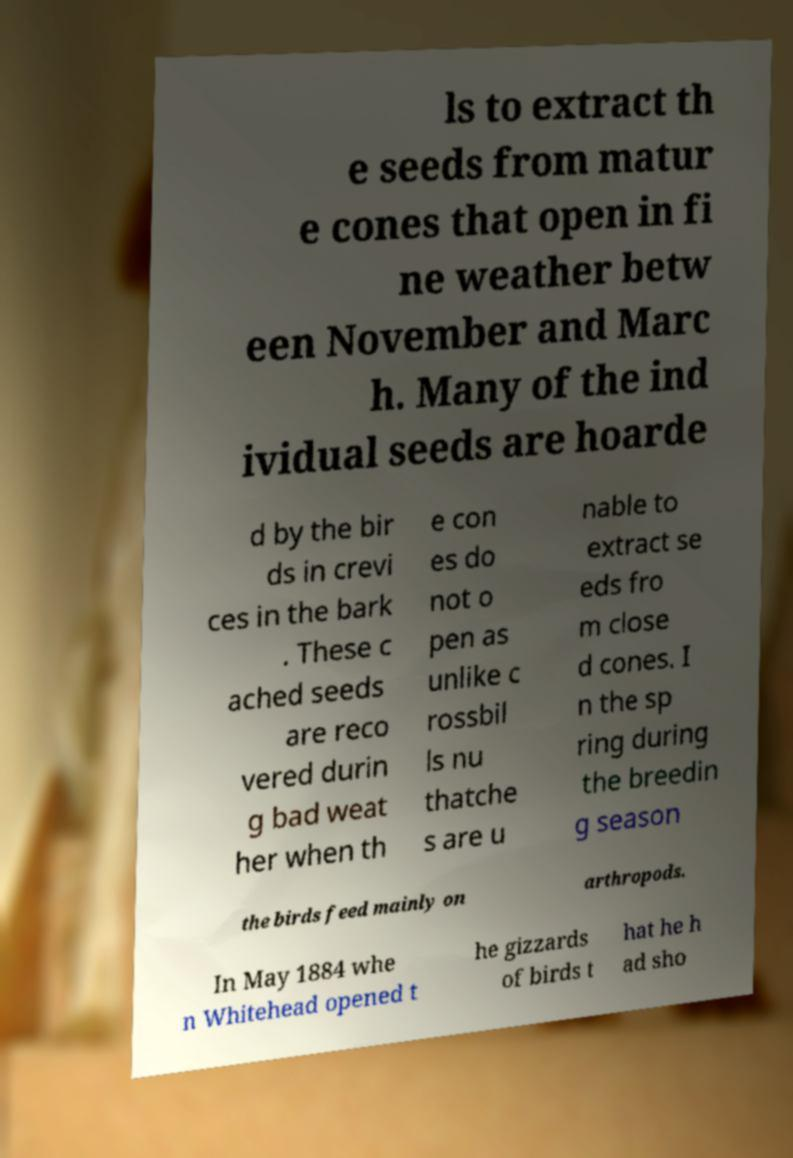What messages or text are displayed in this image? I need them in a readable, typed format. ls to extract th e seeds from matur e cones that open in fi ne weather betw een November and Marc h. Many of the ind ividual seeds are hoarde d by the bir ds in crevi ces in the bark . These c ached seeds are reco vered durin g bad weat her when th e con es do not o pen as unlike c rossbil ls nu thatche s are u nable to extract se eds fro m close d cones. I n the sp ring during the breedin g season the birds feed mainly on arthropods. In May 1884 whe n Whitehead opened t he gizzards of birds t hat he h ad sho 